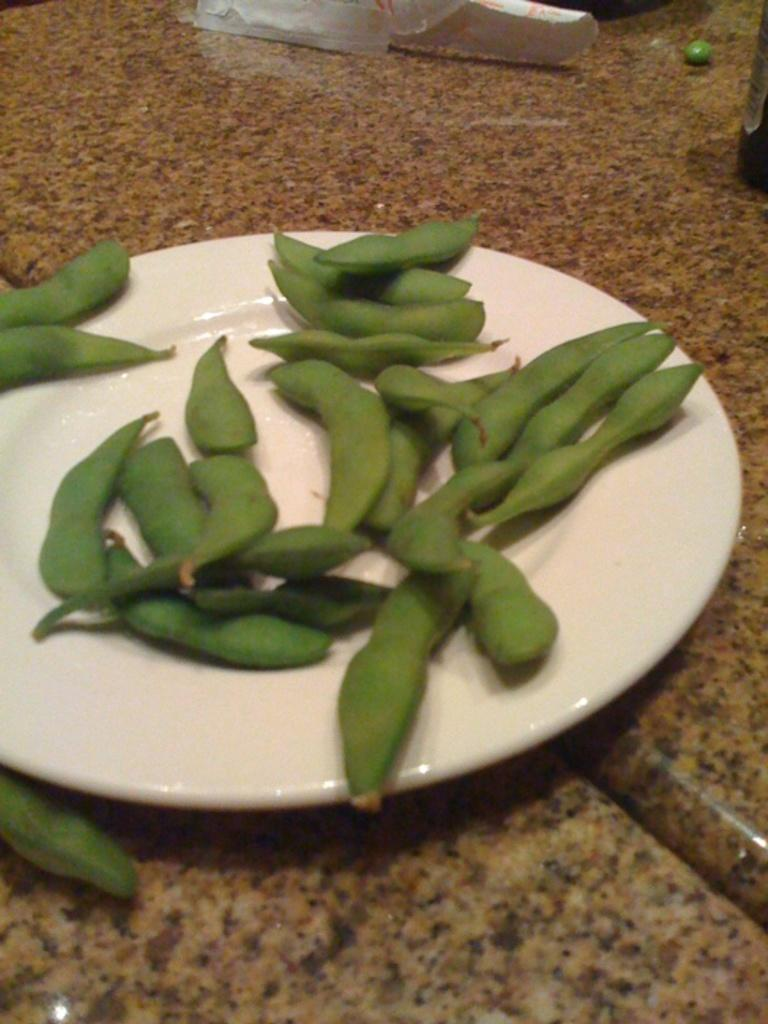What type of food is present in the image? There are broad beans in the image. How are the broad beans arranged or displayed? The broad beans are kept in a white color plate. What is the color of the surface beneath the plate? The plate is on a brown color surface. What invention can be seen in the image? There is no invention present in the image; it features broad beans in a white plate on a brown surface. How many rabbits are visible in the image? There are no rabbits present in the image. 